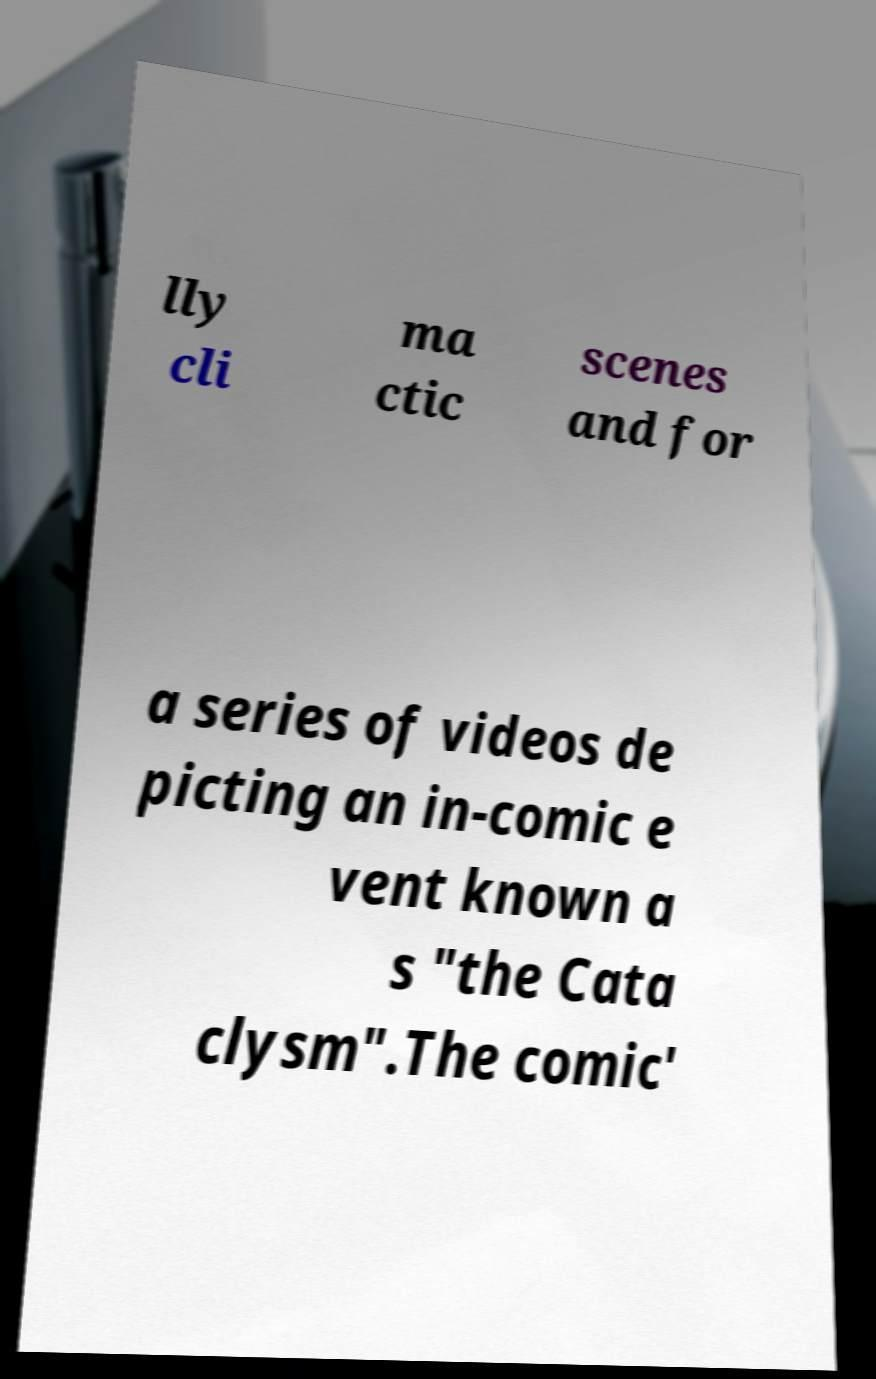Please identify and transcribe the text found in this image. lly cli ma ctic scenes and for a series of videos de picting an in-comic e vent known a s "the Cata clysm".The comic' 